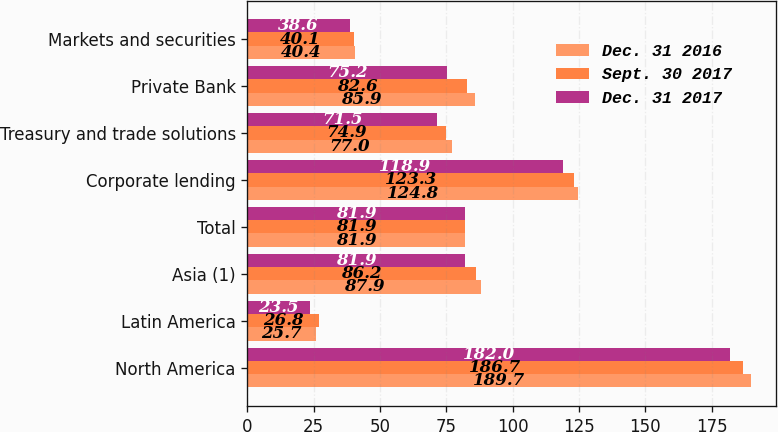Convert chart to OTSL. <chart><loc_0><loc_0><loc_500><loc_500><stacked_bar_chart><ecel><fcel>North America<fcel>Latin America<fcel>Asia (1)<fcel>Total<fcel>Corporate lending<fcel>Treasury and trade solutions<fcel>Private Bank<fcel>Markets and securities<nl><fcel>Dec. 31 2016<fcel>189.7<fcel>25.7<fcel>87.9<fcel>81.9<fcel>124.8<fcel>77<fcel>85.9<fcel>40.4<nl><fcel>Sept. 30 2017<fcel>186.7<fcel>26.8<fcel>86.2<fcel>81.9<fcel>123.3<fcel>74.9<fcel>82.6<fcel>40.1<nl><fcel>Dec. 31 2017<fcel>182<fcel>23.5<fcel>81.9<fcel>81.9<fcel>118.9<fcel>71.5<fcel>75.2<fcel>38.6<nl></chart> 